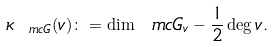<formula> <loc_0><loc_0><loc_500><loc_500>\kappa _ { \ m c G } ( v ) \colon = \dim \ m c G _ { v } - \frac { 1 } { 2 } \deg v .</formula> 